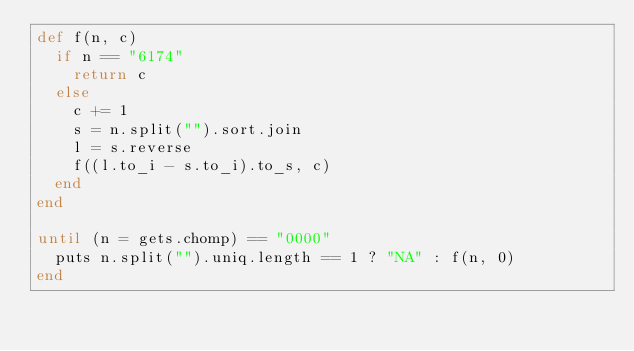Convert code to text. <code><loc_0><loc_0><loc_500><loc_500><_Ruby_>def f(n, c)
  if n == "6174"
    return c
  else
    c += 1
    s = n.split("").sort.join
    l = s.reverse
    f((l.to_i - s.to_i).to_s, c)
  end
end

until (n = gets.chomp) == "0000"
  puts n.split("").uniq.length == 1 ? "NA" : f(n, 0)
end</code> 